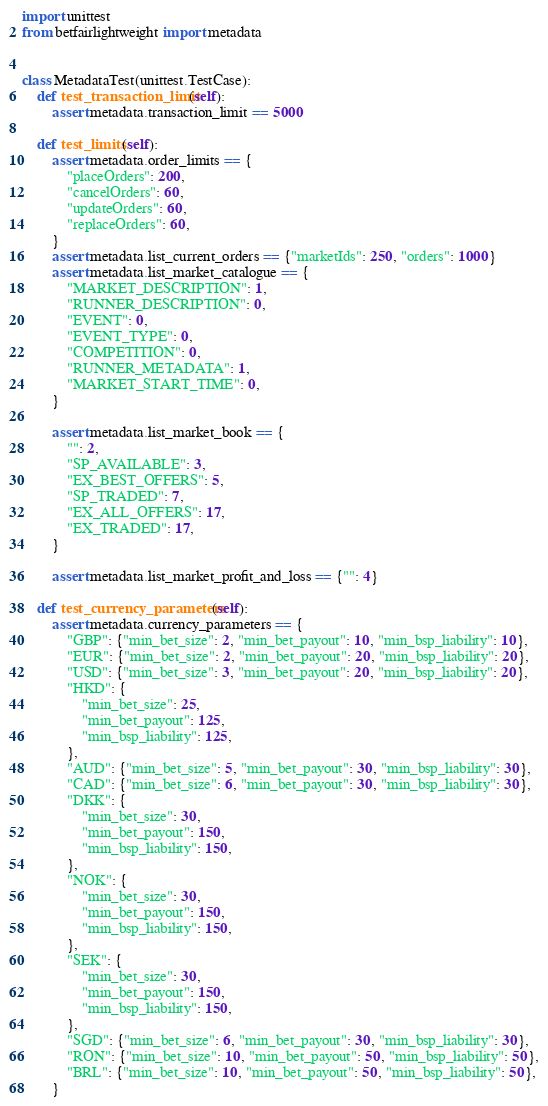Convert code to text. <code><loc_0><loc_0><loc_500><loc_500><_Python_>import unittest
from betfairlightweight import metadata


class MetadataTest(unittest.TestCase):
    def test_transaction_limit(self):
        assert metadata.transaction_limit == 5000

    def test_limits(self):
        assert metadata.order_limits == {
            "placeOrders": 200,
            "cancelOrders": 60,
            "updateOrders": 60,
            "replaceOrders": 60,
        }
        assert metadata.list_current_orders == {"marketIds": 250, "orders": 1000}
        assert metadata.list_market_catalogue == {
            "MARKET_DESCRIPTION": 1,
            "RUNNER_DESCRIPTION": 0,
            "EVENT": 0,
            "EVENT_TYPE": 0,
            "COMPETITION": 0,
            "RUNNER_METADATA": 1,
            "MARKET_START_TIME": 0,
        }

        assert metadata.list_market_book == {
            "": 2,
            "SP_AVAILABLE": 3,
            "EX_BEST_OFFERS": 5,
            "SP_TRADED": 7,
            "EX_ALL_OFFERS": 17,
            "EX_TRADED": 17,
        }

        assert metadata.list_market_profit_and_loss == {"": 4}

    def test_currency_parameters(self):
        assert metadata.currency_parameters == {
            "GBP": {"min_bet_size": 2, "min_bet_payout": 10, "min_bsp_liability": 10},
            "EUR": {"min_bet_size": 2, "min_bet_payout": 20, "min_bsp_liability": 20},
            "USD": {"min_bet_size": 3, "min_bet_payout": 20, "min_bsp_liability": 20},
            "HKD": {
                "min_bet_size": 25,
                "min_bet_payout": 125,
                "min_bsp_liability": 125,
            },
            "AUD": {"min_bet_size": 5, "min_bet_payout": 30, "min_bsp_liability": 30},
            "CAD": {"min_bet_size": 6, "min_bet_payout": 30, "min_bsp_liability": 30},
            "DKK": {
                "min_bet_size": 30,
                "min_bet_payout": 150,
                "min_bsp_liability": 150,
            },
            "NOK": {
                "min_bet_size": 30,
                "min_bet_payout": 150,
                "min_bsp_liability": 150,
            },
            "SEK": {
                "min_bet_size": 30,
                "min_bet_payout": 150,
                "min_bsp_liability": 150,
            },
            "SGD": {"min_bet_size": 6, "min_bet_payout": 30, "min_bsp_liability": 30},
            "RON": {"min_bet_size": 10, "min_bet_payout": 50, "min_bsp_liability": 50},
            "BRL": {"min_bet_size": 10, "min_bet_payout": 50, "min_bsp_liability": 50},
        }
</code> 